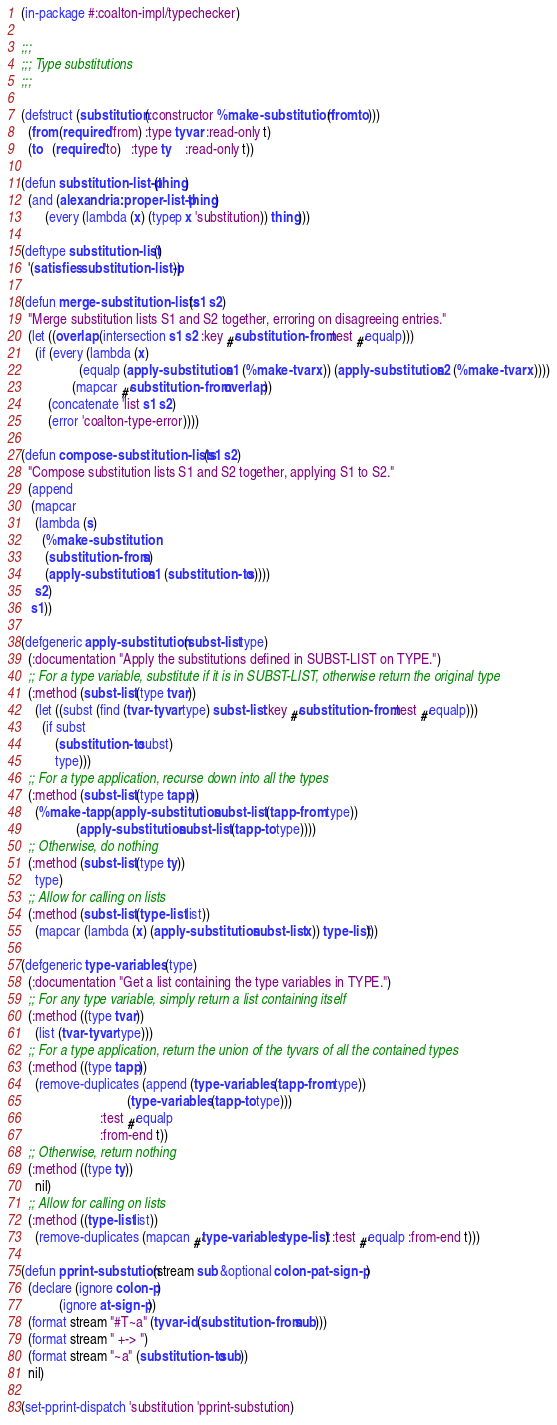Convert code to text. <code><loc_0><loc_0><loc_500><loc_500><_Lisp_>(in-package #:coalton-impl/typechecker)

;;;
;;; Type substitutions
;;;

(defstruct (substitution (:constructor %make-substitution (from to)))
  (from (required 'from) :type tyvar :read-only t)
  (to   (required 'to)   :type ty    :read-only t))

(defun substitution-list-p (thing)
  (and (alexandria:proper-list-p thing)
       (every (lambda (x) (typep x 'substitution)) thing)))

(deftype substitution-list ()
  '(satisfies substitution-list-p))

(defun merge-substitution-lists (s1 s2)
  "Merge substitution lists S1 and S2 together, erroring on disagreeing entries."
  (let ((overlap (intersection s1 s2 :key #'substitution-from :test #'equalp)))
    (if (every (lambda (x)
                 (equalp (apply-substitution s1 (%make-tvar x)) (apply-substitution s2 (%make-tvar x))))
               (mapcar #'substitution-from overlap))
        (concatenate 'list s1 s2)
        (error 'coalton-type-error))))

(defun compose-substitution-lists (s1 s2)
  "Compose substitution lists S1 and S2 together, applying S1 to S2."
  (append
   (mapcar
    (lambda (s)
      (%make-substitution
       (substitution-from s)
       (apply-substitution s1 (substitution-to s))))
    s2)
   s1))

(defgeneric apply-substitution (subst-list type)
  (:documentation "Apply the substitutions defined in SUBST-LIST on TYPE.")
  ;; For a type variable, substitute if it is in SUBST-LIST, otherwise return the original type
  (:method (subst-list (type tvar))
    (let ((subst (find (tvar-tyvar type) subst-list :key #'substitution-from :test #'equalp)))
      (if subst
          (substitution-to subst)
          type)))
  ;; For a type application, recurse down into all the types
  (:method (subst-list (type tapp))
    (%make-tapp (apply-substitution subst-list (tapp-from type))
                (apply-substitution subst-list (tapp-to type))))
  ;; Otherwise, do nothing
  (:method (subst-list (type ty))
    type)
  ;; Allow for calling on lists
  (:method (subst-list (type-list list))
    (mapcar (lambda (x) (apply-substitution subst-list x)) type-list)))

(defgeneric type-variables (type)
  (:documentation "Get a list containing the type variables in TYPE.")
  ;; For any type variable, simply return a list containing itself
  (:method ((type tvar))
    (list (tvar-tyvar type)))
  ;; For a type application, return the union of the tyvars of all the contained types
  (:method ((type tapp))
    (remove-duplicates (append (type-variables (tapp-from type))
                               (type-variables (tapp-to type)))
                       :test #'equalp
                       :from-end t))
  ;; Otherwise, return nothing
  (:method ((type ty))
    nil)
  ;; Allow for calling on lists
  (:method ((type-list list))
    (remove-duplicates (mapcan #'type-variables type-list) :test #'equalp :from-end t)))

(defun pprint-substution (stream sub &optional colon-p at-sign-p)
  (declare (ignore colon-p)
           (ignore at-sign-p))
  (format stream "#T~a" (tyvar-id (substitution-from sub)))
  (format stream " +-> ")
  (format stream "~a" (substitution-to sub))
  nil)

(set-pprint-dispatch 'substitution 'pprint-substution)
</code> 